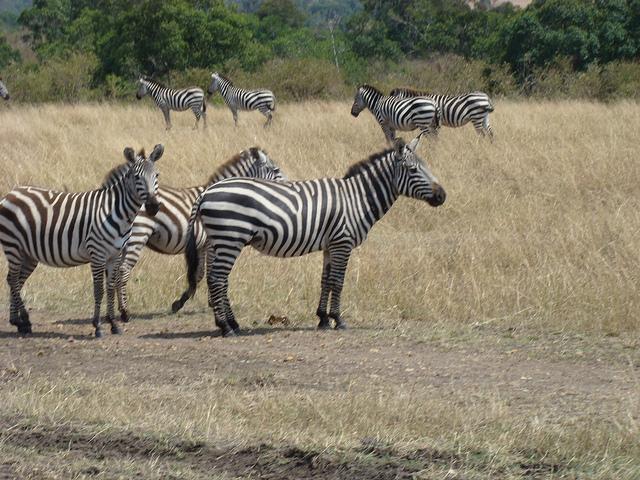What is the zebra on the far right doing?
Be succinct. Standing. Are the zebras in their natural habitat?
Keep it brief. Yes. Do these animals primarily live in Africa?
Write a very short answer. Yes. How many zebra are there total in the picture?
Short answer required. 7. 